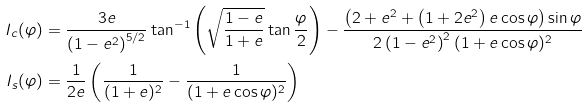<formula> <loc_0><loc_0><loc_500><loc_500>I _ { c } ( \varphi ) & = \frac { 3 e } { \left ( 1 - e ^ { 2 } \right ) ^ { 5 / 2 } } \tan ^ { - 1 } \left ( \sqrt { \frac { 1 - e } { 1 + e } } \tan \frac { \varphi } { 2 } \right ) - \frac { \left ( 2 + e ^ { 2 } + \left ( 1 + 2 e ^ { 2 } \right ) e \cos \varphi \right ) \sin \varphi } { 2 \left ( 1 - e ^ { 2 } \right ) ^ { 2 } ( 1 + e \cos \varphi ) ^ { 2 } } \\ I _ { s } ( \varphi ) & = \frac { 1 } { 2 e } \left ( \frac { 1 } { ( 1 + e ) ^ { 2 } } - \frac { 1 } { ( 1 + e \cos \varphi ) ^ { 2 } } \right )</formula> 